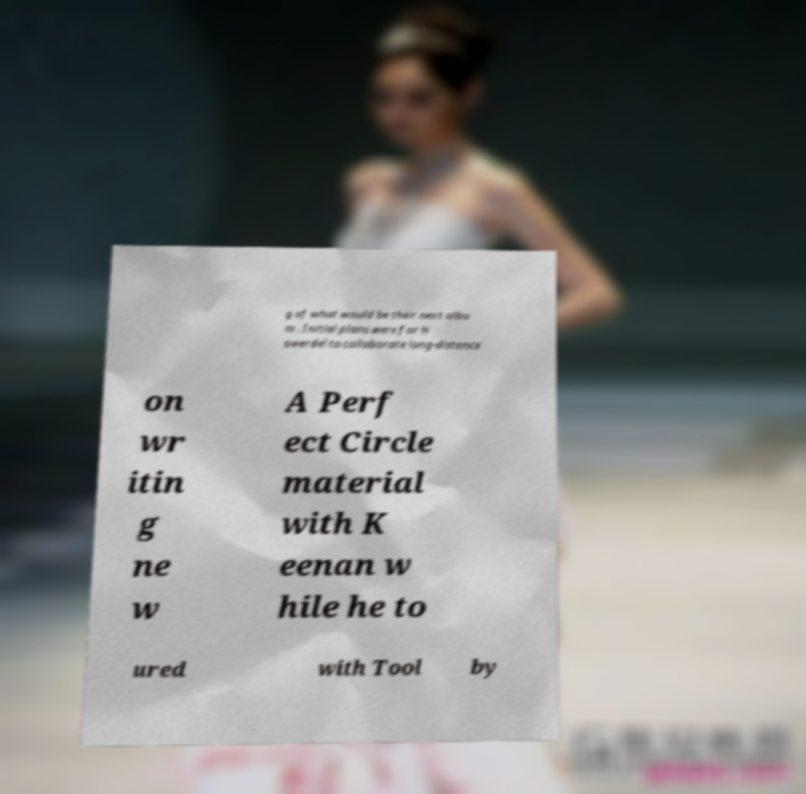There's text embedded in this image that I need extracted. Can you transcribe it verbatim? g of what would be their next albu m . Initial plans were for H owerdel to collaborate long-distance on wr itin g ne w A Perf ect Circle material with K eenan w hile he to ured with Tool by 